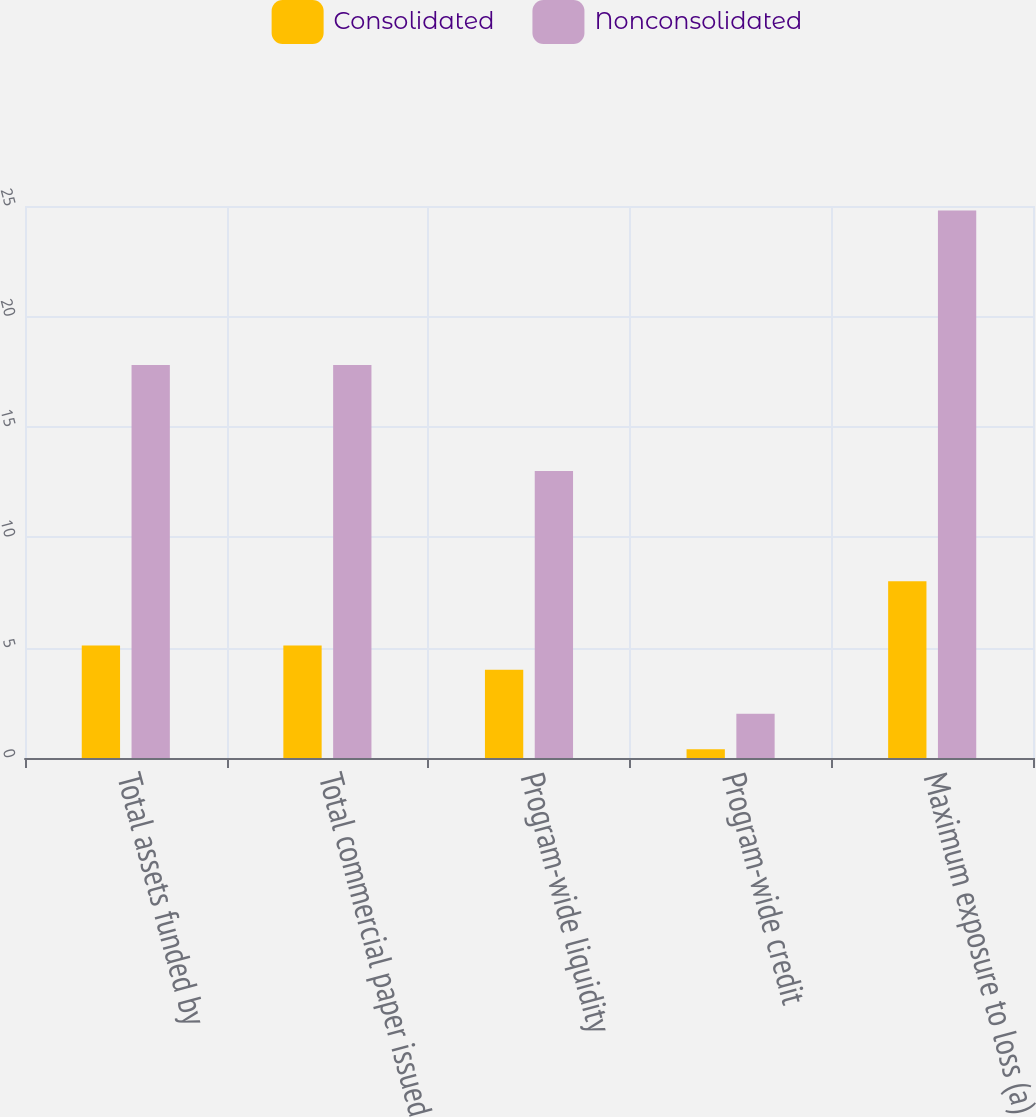Convert chart. <chart><loc_0><loc_0><loc_500><loc_500><stacked_bar_chart><ecel><fcel>Total assets funded by<fcel>Total commercial paper issued<fcel>Program-wide liquidity<fcel>Program-wide credit<fcel>Maximum exposure to loss (a)<nl><fcel>Consolidated<fcel>5.1<fcel>5.1<fcel>4<fcel>0.4<fcel>8<nl><fcel>Nonconsolidated<fcel>17.8<fcel>17.8<fcel>13<fcel>2<fcel>24.8<nl></chart> 